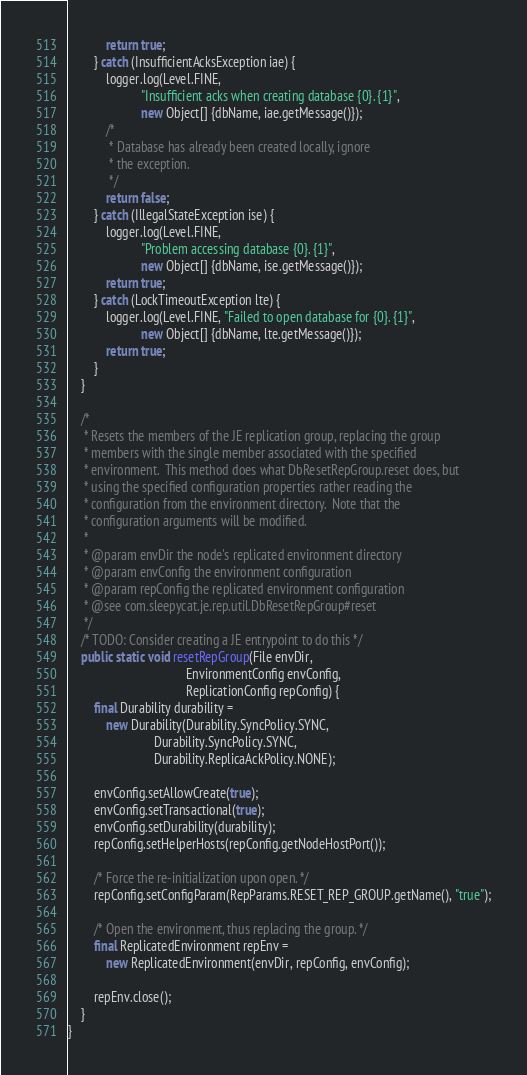<code> <loc_0><loc_0><loc_500><loc_500><_Java_>            return true;
        } catch (InsufficientAcksException iae) {
            logger.log(Level.FINE,
                       "Insufficient acks when creating database {0}. {1}",
                       new Object[] {dbName, iae.getMessage()});
            /*
             * Database has already been created locally, ignore
             * the exception.
             */
            return false;
        } catch (IllegalStateException ise) {
            logger.log(Level.FINE,
                       "Problem accessing database {0}. {1}",
                       new Object[] {dbName, ise.getMessage()});
            return true;
        } catch (LockTimeoutException lte) {
            logger.log(Level.FINE, "Failed to open database for {0}. {1}",
                       new Object[] {dbName, lte.getMessage()});
            return true;
        }
    }

    /*
     * Resets the members of the JE replication group, replacing the group
     * members with the single member associated with the specified
     * environment.  This method does what DbResetRepGroup.reset does, but
     * using the specified configuration properties rather reading the
     * configuration from the environment directory.  Note that the
     * configuration arguments will be modified.
     *
     * @param envDir the node's replicated environment directory
     * @param envConfig the environment configuration
     * @param repConfig the replicated environment configuration
     * @see com.sleepycat.je.rep.util.DbResetRepGroup#reset
     */
    /* TODO: Consider creating a JE entrypoint to do this */
    public static void resetRepGroup(File envDir,
                                     EnvironmentConfig envConfig,
                                     ReplicationConfig repConfig) {
        final Durability durability =
            new Durability(Durability.SyncPolicy.SYNC,
                           Durability.SyncPolicy.SYNC,
                           Durability.ReplicaAckPolicy.NONE);

        envConfig.setAllowCreate(true);
        envConfig.setTransactional(true);
        envConfig.setDurability(durability);
        repConfig.setHelperHosts(repConfig.getNodeHostPort());

        /* Force the re-initialization upon open. */
        repConfig.setConfigParam(RepParams.RESET_REP_GROUP.getName(), "true");

        /* Open the environment, thus replacing the group. */
        final ReplicatedEnvironment repEnv =
            new ReplicatedEnvironment(envDir, repConfig, envConfig);

        repEnv.close();
    }
}
</code> 